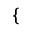Convert formula to latex. <formula><loc_0><loc_0><loc_500><loc_500>\left \{ \begin{array} { r l } \end{array}</formula> 